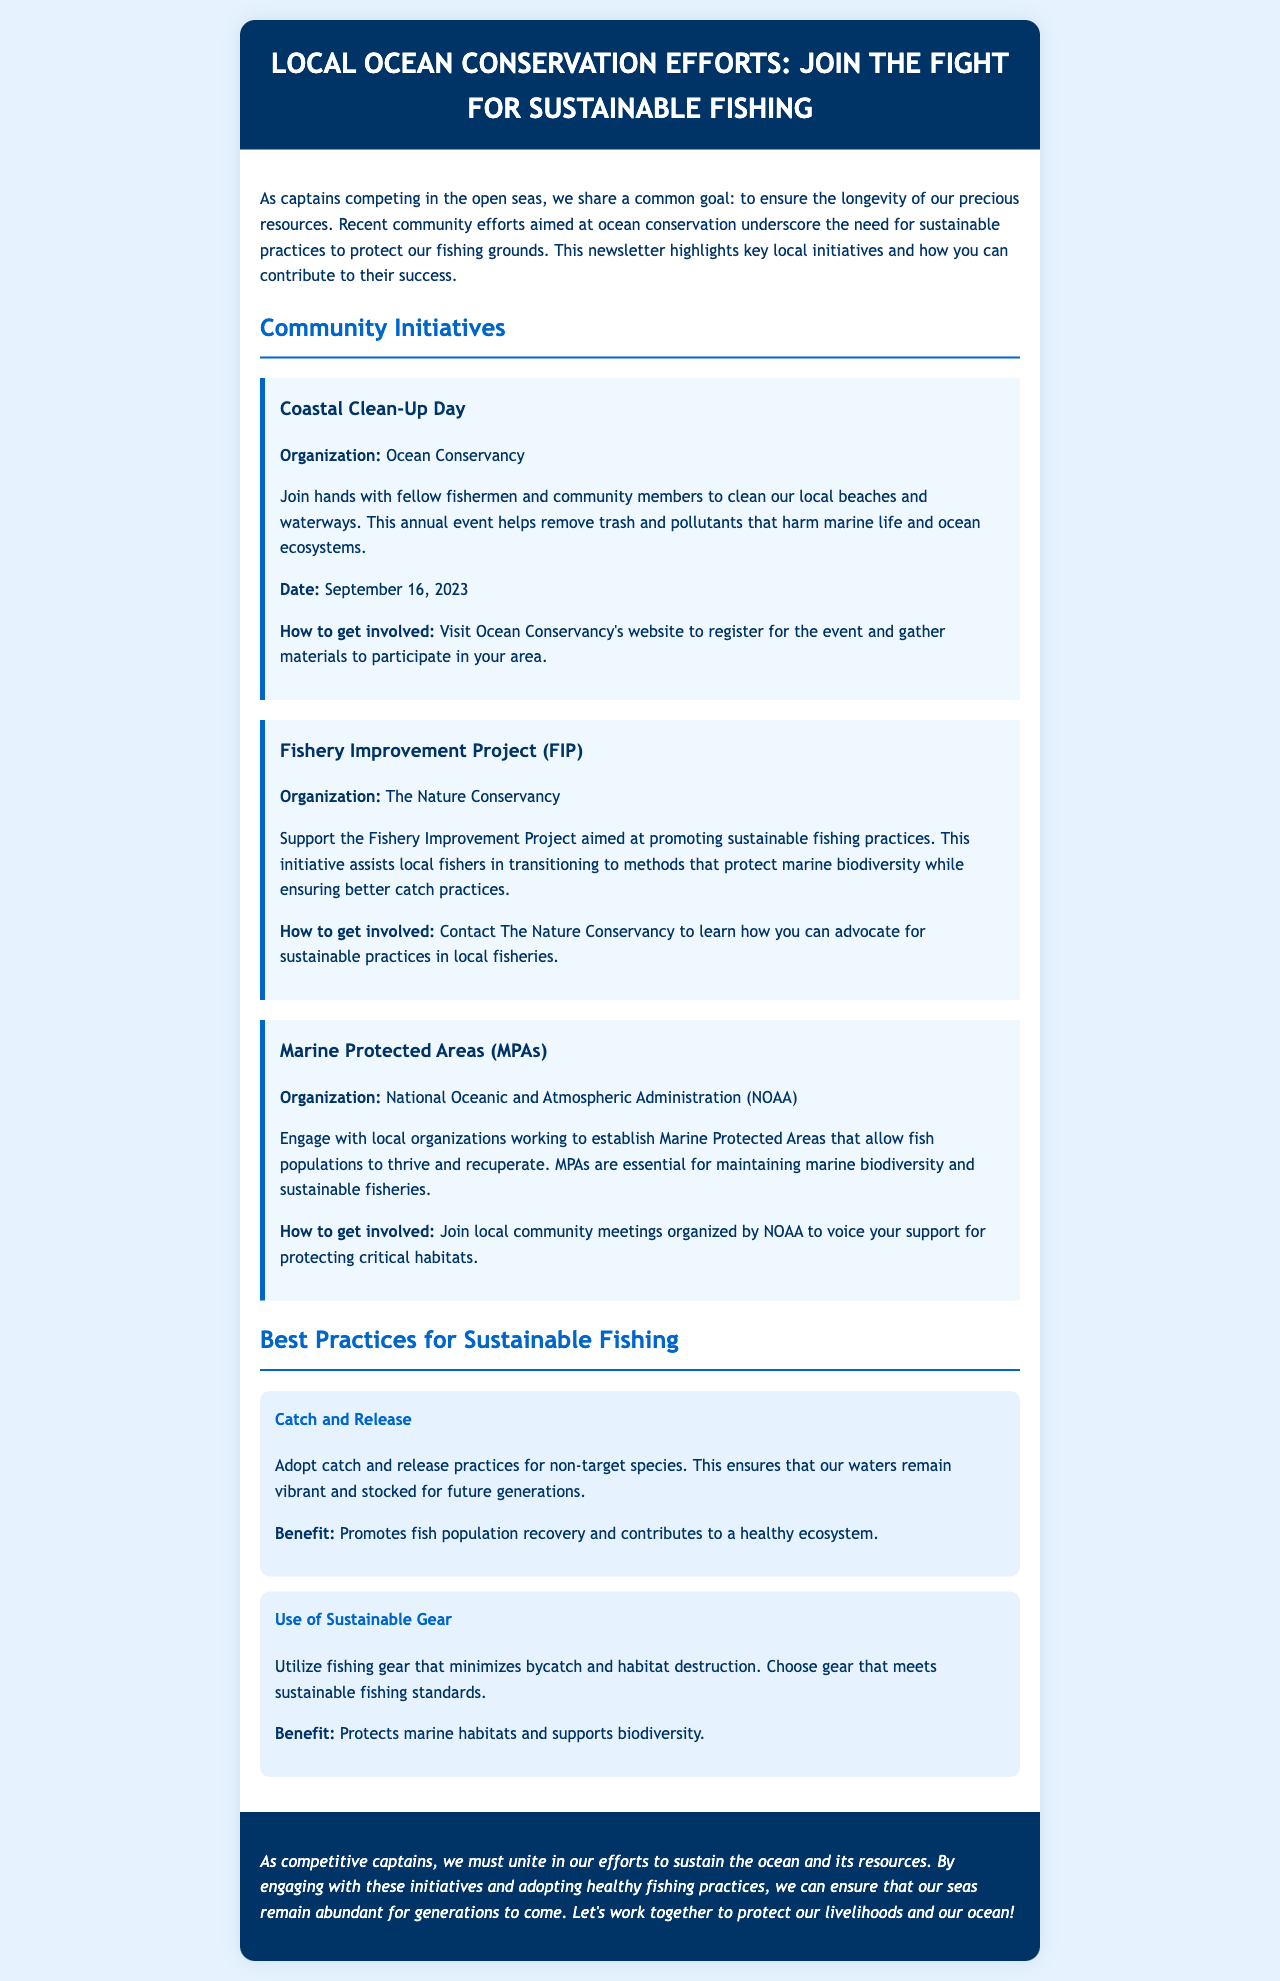what is the name of the newsletter? The newsletter's title is presented at the top of the document, which highlights local ocean conservation efforts.
Answer: Local Ocean Conservation Efforts: Join the Fight for Sustainable Fishing who organized the Coastal Clean-Up Day? The organization responsible for the Coastal Clean-Up Day is mentioned in the document.
Answer: Ocean Conservancy when is the Coastal Clean-Up Day scheduled? The date of the Coastal Clean-Up Day is specified in the initiative section of the document.
Answer: September 16, 2023 which organization is behind the Fishery Improvement Project? The organization associated with the Fishery Improvement Project is indicated in the initiative section.
Answer: The Nature Conservancy what is one benefit of adopting catch and release practices? The document outlines an advantage of using catch and release practices.
Answer: Promotes fish population recovery what is the main goal of Marine Protected Areas? The document implies the primary purpose of establishing Marine Protected Areas in relation to marine ecosystems.
Answer: Maintain marine biodiversity how can you support the establishment of Marine Protected Areas? The document describes how to get involved with local organizations working on MPAs.
Answer: Join local community meetings which fishing method is recommended to minimize bycatch? The best practices section recommends a specific approach to achieving sustainability in fishing.
Answer: Use of Sustainable Gear what kind of practices do the document encourage among competitive captains? The conclusion reflects on the shared practices among captains for successful fishing sustainability.
Answer: Engage with these initiatives and adopt healthy fishing practices 